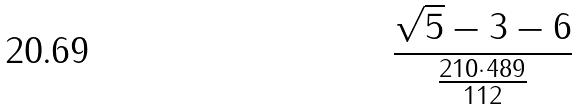Convert formula to latex. <formula><loc_0><loc_0><loc_500><loc_500>\frac { \sqrt { 5 } - 3 - 6 } { \frac { 2 1 0 \cdot 4 8 9 } { 1 1 2 } }</formula> 